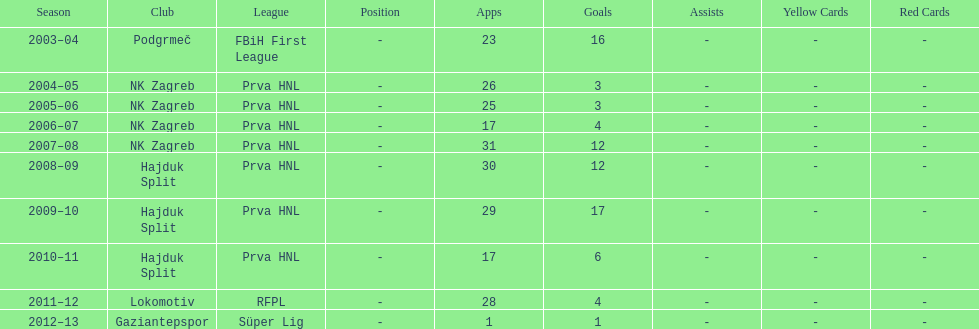What were the names of each club where more than 15 goals were scored in a single season? Podgrmeč, Hajduk Split. 